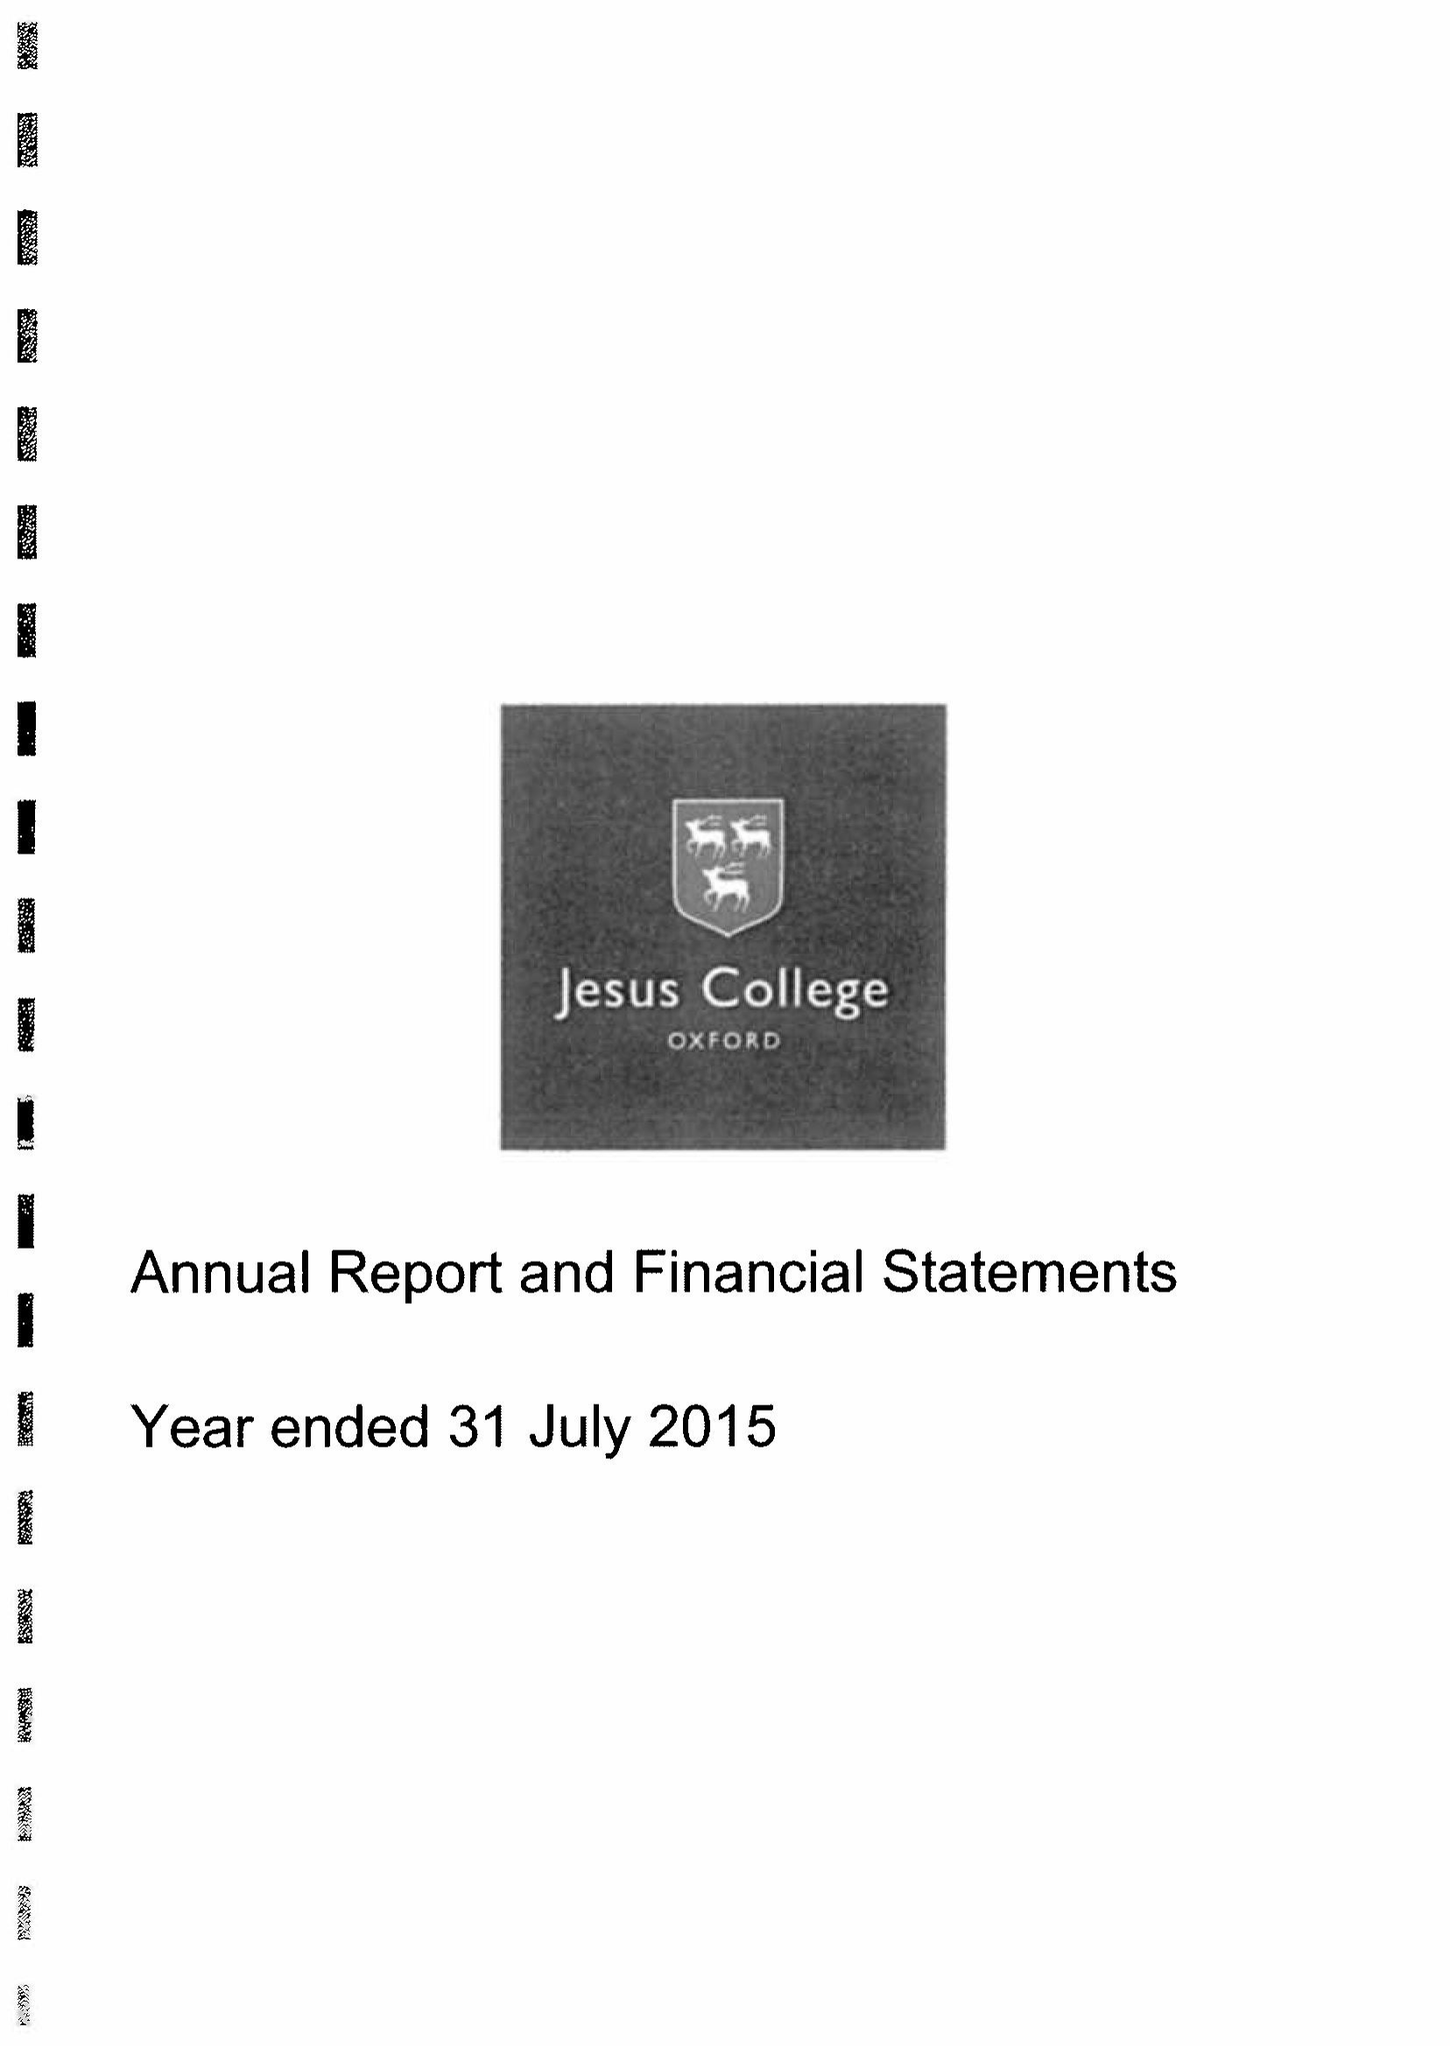What is the value for the report_date?
Answer the question using a single word or phrase. 2015-07-31 